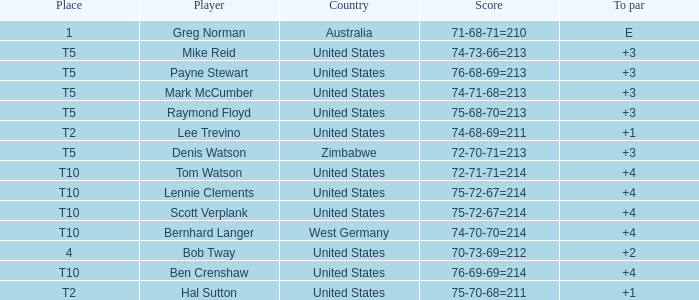Could you parse the entire table? {'header': ['Place', 'Player', 'Country', 'Score', 'To par'], 'rows': [['1', 'Greg Norman', 'Australia', '71-68-71=210', 'E'], ['T5', 'Mike Reid', 'United States', '74-73-66=213', '+3'], ['T5', 'Payne Stewart', 'United States', '76-68-69=213', '+3'], ['T5', 'Mark McCumber', 'United States', '74-71-68=213', '+3'], ['T5', 'Raymond Floyd', 'United States', '75-68-70=213', '+3'], ['T2', 'Lee Trevino', 'United States', '74-68-69=211', '+1'], ['T5', 'Denis Watson', 'Zimbabwe', '72-70-71=213', '+3'], ['T10', 'Tom Watson', 'United States', '72-71-71=214', '+4'], ['T10', 'Lennie Clements', 'United States', '75-72-67=214', '+4'], ['T10', 'Scott Verplank', 'United States', '75-72-67=214', '+4'], ['T10', 'Bernhard Langer', 'West Germany', '74-70-70=214', '+4'], ['4', 'Bob Tway', 'United States', '70-73-69=212', '+2'], ['T10', 'Ben Crenshaw', 'United States', '76-69-69=214', '+4'], ['T2', 'Hal Sutton', 'United States', '75-70-68=211', '+1']]} What is the place of player tom watson? T10. 